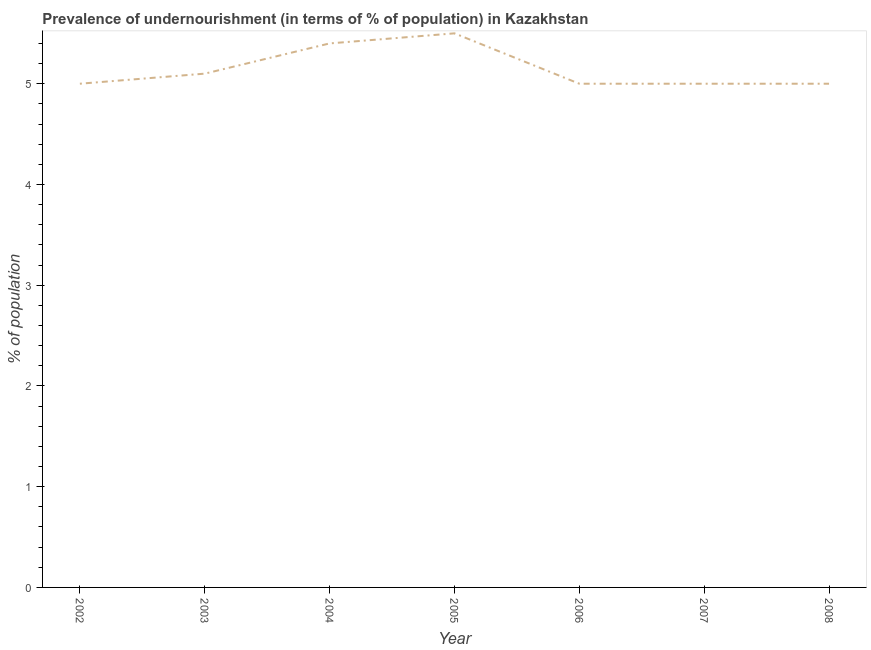What is the percentage of undernourished population in 2008?
Ensure brevity in your answer.  5. Across all years, what is the maximum percentage of undernourished population?
Ensure brevity in your answer.  5.5. Across all years, what is the minimum percentage of undernourished population?
Your answer should be compact. 5. In which year was the percentage of undernourished population minimum?
Provide a short and direct response. 2002. What is the sum of the percentage of undernourished population?
Keep it short and to the point. 36. What is the average percentage of undernourished population per year?
Offer a very short reply. 5.14. In how many years, is the percentage of undernourished population greater than 1.4 %?
Ensure brevity in your answer.  7. What is the ratio of the percentage of undernourished population in 2006 to that in 2008?
Your answer should be compact. 1. What is the difference between the highest and the second highest percentage of undernourished population?
Your answer should be compact. 0.1. Is the sum of the percentage of undernourished population in 2002 and 2006 greater than the maximum percentage of undernourished population across all years?
Give a very brief answer. Yes. How many lines are there?
Provide a succinct answer. 1. How many years are there in the graph?
Keep it short and to the point. 7. Are the values on the major ticks of Y-axis written in scientific E-notation?
Give a very brief answer. No. Does the graph contain any zero values?
Give a very brief answer. No. Does the graph contain grids?
Provide a short and direct response. No. What is the title of the graph?
Offer a terse response. Prevalence of undernourishment (in terms of % of population) in Kazakhstan. What is the label or title of the X-axis?
Ensure brevity in your answer.  Year. What is the label or title of the Y-axis?
Keep it short and to the point. % of population. What is the % of population in 2003?
Your answer should be compact. 5.1. What is the % of population in 2008?
Provide a succinct answer. 5. What is the difference between the % of population in 2003 and 2004?
Offer a terse response. -0.3. What is the difference between the % of population in 2003 and 2005?
Your answer should be very brief. -0.4. What is the difference between the % of population in 2003 and 2007?
Provide a succinct answer. 0.1. What is the difference between the % of population in 2003 and 2008?
Give a very brief answer. 0.1. What is the difference between the % of population in 2004 and 2006?
Offer a terse response. 0.4. What is the difference between the % of population in 2005 and 2007?
Provide a short and direct response. 0.5. What is the difference between the % of population in 2005 and 2008?
Ensure brevity in your answer.  0.5. What is the difference between the % of population in 2006 and 2008?
Give a very brief answer. 0. What is the ratio of the % of population in 2002 to that in 2003?
Provide a short and direct response. 0.98. What is the ratio of the % of population in 2002 to that in 2004?
Your answer should be very brief. 0.93. What is the ratio of the % of population in 2002 to that in 2005?
Your response must be concise. 0.91. What is the ratio of the % of population in 2002 to that in 2006?
Provide a short and direct response. 1. What is the ratio of the % of population in 2003 to that in 2004?
Make the answer very short. 0.94. What is the ratio of the % of population in 2003 to that in 2005?
Your answer should be compact. 0.93. What is the ratio of the % of population in 2003 to that in 2008?
Provide a short and direct response. 1.02. What is the ratio of the % of population in 2004 to that in 2006?
Provide a short and direct response. 1.08. What is the ratio of the % of population in 2004 to that in 2008?
Your answer should be very brief. 1.08. What is the ratio of the % of population in 2005 to that in 2006?
Keep it short and to the point. 1.1. What is the ratio of the % of population in 2005 to that in 2008?
Offer a terse response. 1.1. What is the ratio of the % of population in 2006 to that in 2007?
Ensure brevity in your answer.  1. What is the ratio of the % of population in 2007 to that in 2008?
Your response must be concise. 1. 